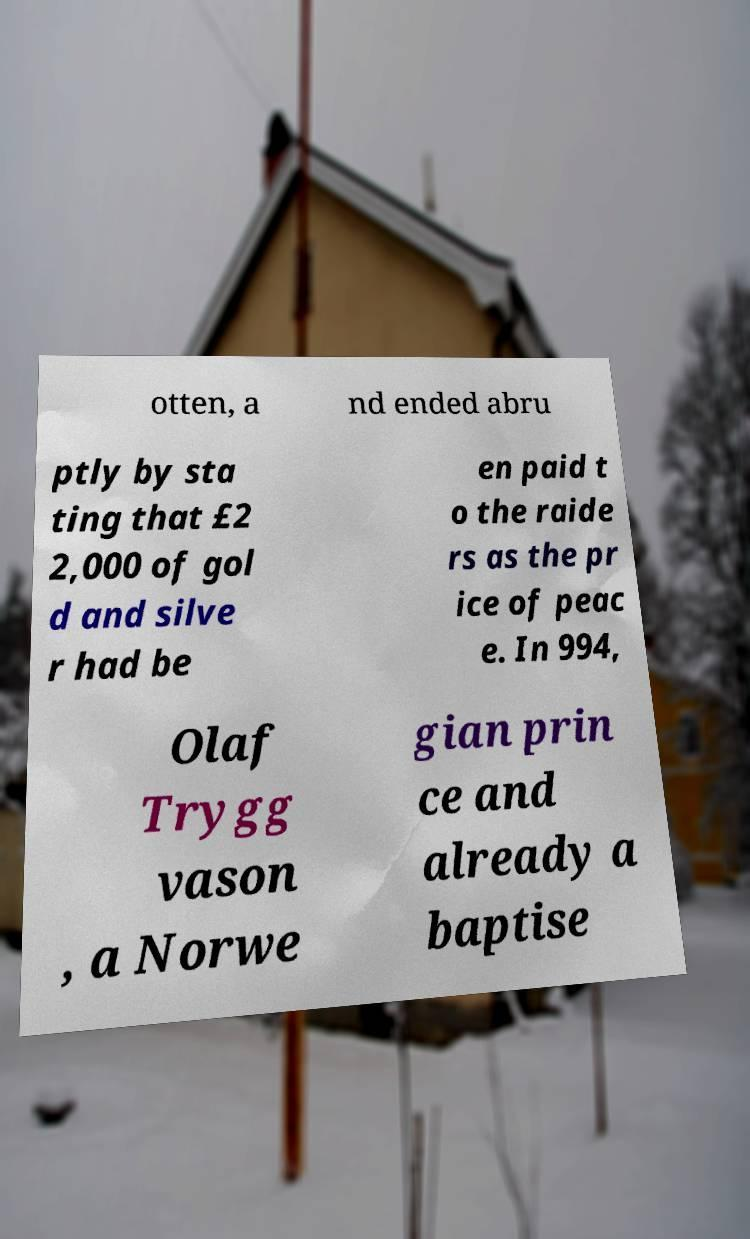Could you extract and type out the text from this image? otten, a nd ended abru ptly by sta ting that £2 2,000 of gol d and silve r had be en paid t o the raide rs as the pr ice of peac e. In 994, Olaf Trygg vason , a Norwe gian prin ce and already a baptise 